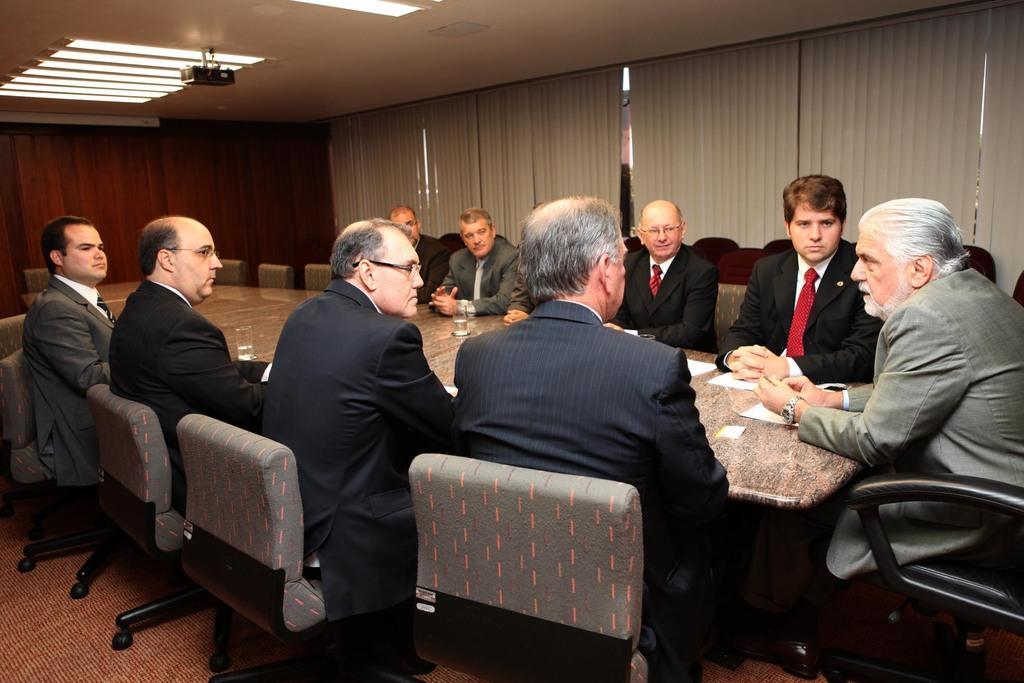Please provide a concise description of this image. In this image there are some people who are sitting around the table, and on the table there are some papers and glasses. And in the background there is a window, curtains and at the top there is one projector and some lights. In the background there is a wall and at the bottom there is floor. 